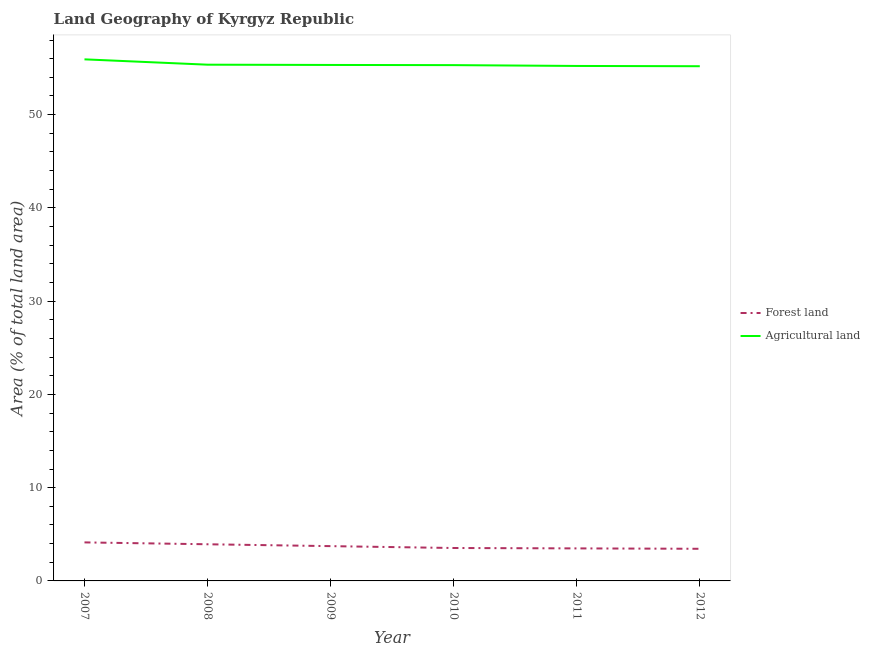How many different coloured lines are there?
Keep it short and to the point. 2. What is the percentage of land area under forests in 2010?
Give a very brief answer. 3.53. Across all years, what is the maximum percentage of land area under agriculture?
Provide a succinct answer. 55.93. Across all years, what is the minimum percentage of land area under agriculture?
Your answer should be very brief. 55.19. What is the total percentage of land area under agriculture in the graph?
Your answer should be very brief. 332.34. What is the difference between the percentage of land area under agriculture in 2010 and that in 2012?
Your answer should be compact. 0.12. What is the difference between the percentage of land area under agriculture in 2008 and the percentage of land area under forests in 2007?
Your response must be concise. 51.22. What is the average percentage of land area under agriculture per year?
Ensure brevity in your answer.  55.39. In the year 2010, what is the difference between the percentage of land area under agriculture and percentage of land area under forests?
Provide a succinct answer. 51.78. In how many years, is the percentage of land area under agriculture greater than 54 %?
Offer a very short reply. 6. What is the ratio of the percentage of land area under agriculture in 2010 to that in 2011?
Offer a terse response. 1. Is the difference between the percentage of land area under forests in 2009 and 2012 greater than the difference between the percentage of land area under agriculture in 2009 and 2012?
Keep it short and to the point. Yes. What is the difference between the highest and the second highest percentage of land area under agriculture?
Your answer should be very brief. 0.57. What is the difference between the highest and the lowest percentage of land area under forests?
Your answer should be compact. 0.68. Is the sum of the percentage of land area under agriculture in 2007 and 2010 greater than the maximum percentage of land area under forests across all years?
Offer a terse response. Yes. Is the percentage of land area under forests strictly greater than the percentage of land area under agriculture over the years?
Give a very brief answer. No. How many lines are there?
Ensure brevity in your answer.  2. How many years are there in the graph?
Your response must be concise. 6. What is the difference between two consecutive major ticks on the Y-axis?
Provide a succinct answer. 10. Where does the legend appear in the graph?
Offer a terse response. Center right. How are the legend labels stacked?
Keep it short and to the point. Vertical. What is the title of the graph?
Provide a short and direct response. Land Geography of Kyrgyz Republic. Does "Net savings(excluding particulate emission damage)" appear as one of the legend labels in the graph?
Offer a very short reply. No. What is the label or title of the Y-axis?
Give a very brief answer. Area (% of total land area). What is the Area (% of total land area) in Forest land in 2007?
Your response must be concise. 4.13. What is the Area (% of total land area) in Agricultural land in 2007?
Make the answer very short. 55.93. What is the Area (% of total land area) of Forest land in 2008?
Make the answer very short. 3.93. What is the Area (% of total land area) in Agricultural land in 2008?
Give a very brief answer. 55.36. What is the Area (% of total land area) of Forest land in 2009?
Give a very brief answer. 3.73. What is the Area (% of total land area) of Agricultural land in 2009?
Give a very brief answer. 55.33. What is the Area (% of total land area) of Forest land in 2010?
Offer a very short reply. 3.53. What is the Area (% of total land area) of Agricultural land in 2010?
Provide a succinct answer. 55.31. What is the Area (% of total land area) of Forest land in 2011?
Your answer should be compact. 3.49. What is the Area (% of total land area) in Agricultural land in 2011?
Offer a very short reply. 55.22. What is the Area (% of total land area) in Forest land in 2012?
Your response must be concise. 3.45. What is the Area (% of total land area) in Agricultural land in 2012?
Give a very brief answer. 55.19. Across all years, what is the maximum Area (% of total land area) of Forest land?
Make the answer very short. 4.13. Across all years, what is the maximum Area (% of total land area) in Agricultural land?
Your answer should be very brief. 55.93. Across all years, what is the minimum Area (% of total land area) in Forest land?
Provide a short and direct response. 3.45. Across all years, what is the minimum Area (% of total land area) of Agricultural land?
Ensure brevity in your answer.  55.19. What is the total Area (% of total land area) in Forest land in the graph?
Give a very brief answer. 22.26. What is the total Area (% of total land area) in Agricultural land in the graph?
Give a very brief answer. 332.34. What is the difference between the Area (% of total land area) in Forest land in 2007 and that in 2008?
Provide a succinct answer. 0.2. What is the difference between the Area (% of total land area) of Agricultural land in 2007 and that in 2008?
Give a very brief answer. 0.57. What is the difference between the Area (% of total land area) in Forest land in 2007 and that in 2009?
Offer a very short reply. 0.4. What is the difference between the Area (% of total land area) in Agricultural land in 2007 and that in 2009?
Provide a succinct answer. 0.6. What is the difference between the Area (% of total land area) in Forest land in 2007 and that in 2010?
Your response must be concise. 0.6. What is the difference between the Area (% of total land area) of Agricultural land in 2007 and that in 2010?
Your answer should be compact. 0.62. What is the difference between the Area (% of total land area) of Forest land in 2007 and that in 2011?
Ensure brevity in your answer.  0.64. What is the difference between the Area (% of total land area) of Agricultural land in 2007 and that in 2011?
Keep it short and to the point. 0.71. What is the difference between the Area (% of total land area) in Forest land in 2007 and that in 2012?
Provide a succinct answer. 0.69. What is the difference between the Area (% of total land area) in Agricultural land in 2007 and that in 2012?
Your answer should be compact. 0.74. What is the difference between the Area (% of total land area) in Forest land in 2008 and that in 2009?
Provide a short and direct response. 0.2. What is the difference between the Area (% of total land area) in Agricultural land in 2008 and that in 2009?
Your answer should be very brief. 0.03. What is the difference between the Area (% of total land area) in Forest land in 2008 and that in 2010?
Your answer should be compact. 0.4. What is the difference between the Area (% of total land area) of Agricultural land in 2008 and that in 2010?
Offer a very short reply. 0.05. What is the difference between the Area (% of total land area) of Forest land in 2008 and that in 2011?
Keep it short and to the point. 0.44. What is the difference between the Area (% of total land area) in Agricultural land in 2008 and that in 2011?
Your answer should be very brief. 0.14. What is the difference between the Area (% of total land area) in Forest land in 2008 and that in 2012?
Offer a very short reply. 0.48. What is the difference between the Area (% of total land area) in Agricultural land in 2008 and that in 2012?
Ensure brevity in your answer.  0.16. What is the difference between the Area (% of total land area) of Forest land in 2009 and that in 2010?
Give a very brief answer. 0.2. What is the difference between the Area (% of total land area) of Agricultural land in 2009 and that in 2010?
Provide a succinct answer. 0.02. What is the difference between the Area (% of total land area) of Forest land in 2009 and that in 2011?
Give a very brief answer. 0.24. What is the difference between the Area (% of total land area) in Agricultural land in 2009 and that in 2011?
Give a very brief answer. 0.11. What is the difference between the Area (% of total land area) of Forest land in 2009 and that in 2012?
Provide a short and direct response. 0.28. What is the difference between the Area (% of total land area) in Agricultural land in 2009 and that in 2012?
Make the answer very short. 0.14. What is the difference between the Area (% of total land area) of Forest land in 2010 and that in 2011?
Ensure brevity in your answer.  0.04. What is the difference between the Area (% of total land area) in Agricultural land in 2010 and that in 2011?
Provide a succinct answer. 0.09. What is the difference between the Area (% of total land area) in Forest land in 2010 and that in 2012?
Keep it short and to the point. 0.08. What is the difference between the Area (% of total land area) in Agricultural land in 2010 and that in 2012?
Keep it short and to the point. 0.12. What is the difference between the Area (% of total land area) of Forest land in 2011 and that in 2012?
Your answer should be compact. 0.04. What is the difference between the Area (% of total land area) of Agricultural land in 2011 and that in 2012?
Provide a succinct answer. 0.03. What is the difference between the Area (% of total land area) in Forest land in 2007 and the Area (% of total land area) in Agricultural land in 2008?
Make the answer very short. -51.22. What is the difference between the Area (% of total land area) of Forest land in 2007 and the Area (% of total land area) of Agricultural land in 2009?
Provide a succinct answer. -51.2. What is the difference between the Area (% of total land area) of Forest land in 2007 and the Area (% of total land area) of Agricultural land in 2010?
Offer a very short reply. -51.18. What is the difference between the Area (% of total land area) of Forest land in 2007 and the Area (% of total land area) of Agricultural land in 2011?
Provide a succinct answer. -51.09. What is the difference between the Area (% of total land area) of Forest land in 2007 and the Area (% of total land area) of Agricultural land in 2012?
Give a very brief answer. -51.06. What is the difference between the Area (% of total land area) of Forest land in 2008 and the Area (% of total land area) of Agricultural land in 2009?
Provide a succinct answer. -51.4. What is the difference between the Area (% of total land area) in Forest land in 2008 and the Area (% of total land area) in Agricultural land in 2010?
Your answer should be compact. -51.38. What is the difference between the Area (% of total land area) in Forest land in 2008 and the Area (% of total land area) in Agricultural land in 2011?
Provide a succinct answer. -51.29. What is the difference between the Area (% of total land area) of Forest land in 2008 and the Area (% of total land area) of Agricultural land in 2012?
Give a very brief answer. -51.26. What is the difference between the Area (% of total land area) of Forest land in 2009 and the Area (% of total land area) of Agricultural land in 2010?
Offer a very short reply. -51.58. What is the difference between the Area (% of total land area) of Forest land in 2009 and the Area (% of total land area) of Agricultural land in 2011?
Your answer should be very brief. -51.49. What is the difference between the Area (% of total land area) in Forest land in 2009 and the Area (% of total land area) in Agricultural land in 2012?
Ensure brevity in your answer.  -51.46. What is the difference between the Area (% of total land area) of Forest land in 2010 and the Area (% of total land area) of Agricultural land in 2011?
Keep it short and to the point. -51.69. What is the difference between the Area (% of total land area) in Forest land in 2010 and the Area (% of total land area) in Agricultural land in 2012?
Your answer should be very brief. -51.66. What is the difference between the Area (% of total land area) of Forest land in 2011 and the Area (% of total land area) of Agricultural land in 2012?
Offer a terse response. -51.7. What is the average Area (% of total land area) in Forest land per year?
Your answer should be compact. 3.71. What is the average Area (% of total land area) in Agricultural land per year?
Provide a short and direct response. 55.39. In the year 2007, what is the difference between the Area (% of total land area) in Forest land and Area (% of total land area) in Agricultural land?
Make the answer very short. -51.8. In the year 2008, what is the difference between the Area (% of total land area) in Forest land and Area (% of total land area) in Agricultural land?
Provide a succinct answer. -51.43. In the year 2009, what is the difference between the Area (% of total land area) of Forest land and Area (% of total land area) of Agricultural land?
Keep it short and to the point. -51.6. In the year 2010, what is the difference between the Area (% of total land area) of Forest land and Area (% of total land area) of Agricultural land?
Provide a succinct answer. -51.78. In the year 2011, what is the difference between the Area (% of total land area) in Forest land and Area (% of total land area) in Agricultural land?
Make the answer very short. -51.73. In the year 2012, what is the difference between the Area (% of total land area) of Forest land and Area (% of total land area) of Agricultural land?
Offer a very short reply. -51.75. What is the ratio of the Area (% of total land area) of Forest land in 2007 to that in 2008?
Your response must be concise. 1.05. What is the ratio of the Area (% of total land area) of Agricultural land in 2007 to that in 2008?
Provide a short and direct response. 1.01. What is the ratio of the Area (% of total land area) in Forest land in 2007 to that in 2009?
Give a very brief answer. 1.11. What is the ratio of the Area (% of total land area) in Agricultural land in 2007 to that in 2009?
Offer a very short reply. 1.01. What is the ratio of the Area (% of total land area) of Forest land in 2007 to that in 2010?
Offer a very short reply. 1.17. What is the ratio of the Area (% of total land area) of Agricultural land in 2007 to that in 2010?
Your response must be concise. 1.01. What is the ratio of the Area (% of total land area) in Forest land in 2007 to that in 2011?
Offer a terse response. 1.18. What is the ratio of the Area (% of total land area) in Agricultural land in 2007 to that in 2011?
Your answer should be very brief. 1.01. What is the ratio of the Area (% of total land area) in Forest land in 2007 to that in 2012?
Offer a terse response. 1.2. What is the ratio of the Area (% of total land area) of Agricultural land in 2007 to that in 2012?
Your response must be concise. 1.01. What is the ratio of the Area (% of total land area) in Forest land in 2008 to that in 2009?
Your answer should be very brief. 1.05. What is the ratio of the Area (% of total land area) in Forest land in 2008 to that in 2010?
Your response must be concise. 1.11. What is the ratio of the Area (% of total land area) in Agricultural land in 2008 to that in 2010?
Provide a succinct answer. 1. What is the ratio of the Area (% of total land area) of Forest land in 2008 to that in 2011?
Provide a short and direct response. 1.13. What is the ratio of the Area (% of total land area) of Agricultural land in 2008 to that in 2011?
Offer a very short reply. 1. What is the ratio of the Area (% of total land area) of Forest land in 2008 to that in 2012?
Your response must be concise. 1.14. What is the ratio of the Area (% of total land area) of Forest land in 2009 to that in 2010?
Ensure brevity in your answer.  1.06. What is the ratio of the Area (% of total land area) in Agricultural land in 2009 to that in 2010?
Offer a terse response. 1. What is the ratio of the Area (% of total land area) of Forest land in 2009 to that in 2011?
Your response must be concise. 1.07. What is the ratio of the Area (% of total land area) in Agricultural land in 2009 to that in 2011?
Ensure brevity in your answer.  1. What is the ratio of the Area (% of total land area) of Forest land in 2009 to that in 2012?
Your response must be concise. 1.08. What is the ratio of the Area (% of total land area) in Agricultural land in 2009 to that in 2012?
Your answer should be compact. 1. What is the ratio of the Area (% of total land area) in Forest land in 2010 to that in 2011?
Offer a terse response. 1.01. What is the ratio of the Area (% of total land area) of Forest land in 2010 to that in 2012?
Offer a very short reply. 1.02. What is the ratio of the Area (% of total land area) of Forest land in 2011 to that in 2012?
Your answer should be compact. 1.01. What is the ratio of the Area (% of total land area) in Agricultural land in 2011 to that in 2012?
Keep it short and to the point. 1. What is the difference between the highest and the second highest Area (% of total land area) in Forest land?
Your answer should be very brief. 0.2. What is the difference between the highest and the second highest Area (% of total land area) of Agricultural land?
Your response must be concise. 0.57. What is the difference between the highest and the lowest Area (% of total land area) of Forest land?
Ensure brevity in your answer.  0.69. What is the difference between the highest and the lowest Area (% of total land area) in Agricultural land?
Make the answer very short. 0.74. 